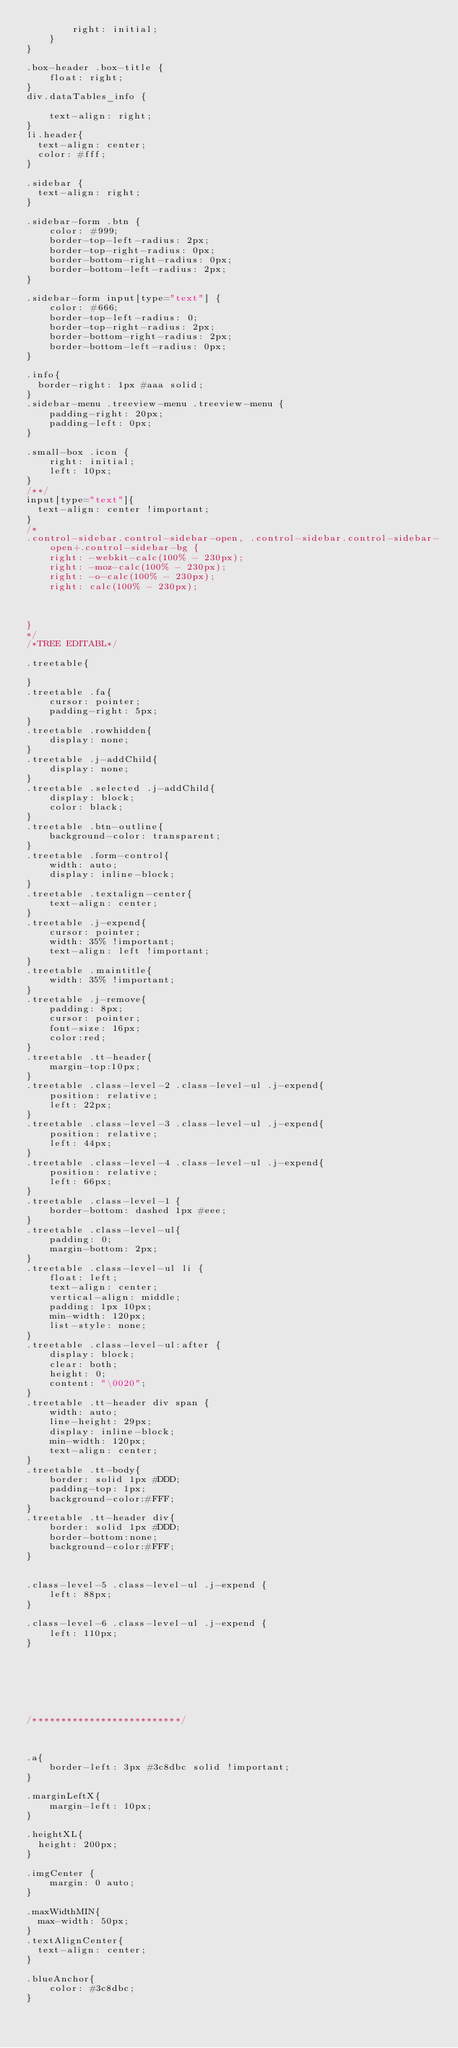<code> <loc_0><loc_0><loc_500><loc_500><_CSS_>        right: initial;
    }
}

.box-header .box-title {
    float: right;
}
div.dataTables_info {

    text-align: right;
}
li.header{
	text-align: center;
	color: #fff;
}

.sidebar {
	text-align: right;
}

.sidebar-form .btn {
    color: #999;
    border-top-left-radius: 2px;
    border-top-right-radius: 0px;
    border-bottom-right-radius: 0px;
    border-bottom-left-radius: 2px;
}

.sidebar-form input[type="text"] {
    color: #666;
    border-top-left-radius: 0;
    border-top-right-radius: 2px;
    border-bottom-right-radius: 2px;
    border-bottom-left-radius: 0px;    
}

.info{
	border-right: 1px #aaa solid;
}
.sidebar-menu .treeview-menu .treeview-menu {
    padding-right: 20px;
    padding-left: 0px;
}

.small-box .icon {
    right: initial;
    left: 10px;
}
/**/
input[type="text"]{
	text-align: center !important;
}
/*
.control-sidebar.control-sidebar-open, .control-sidebar.control-sidebar-open+.control-sidebar-bg {
    right: -webkit-calc(100% - 230px);
    right: -moz-calc(100% - 230px);
    right: -o-calc(100% - 230px);
    right: calc(100% - 230px);



}
*/
/*TREE EDITABL*/

.treetable{

}
.treetable .fa{
    cursor: pointer;
    padding-right: 5px;
}
.treetable .rowhidden{
    display: none;
}
.treetable .j-addChild{
    display: none;
}
.treetable .selected .j-addChild{
    display: block;
    color: black;
}
.treetable .btn-outline{
    background-color: transparent;
}
.treetable .form-control{
    width: auto;
    display: inline-block;
}
.treetable .textalign-center{
    text-align: center;
}
.treetable .j-expend{
    cursor: pointer;
    width: 35% !important;
    text-align: left !important;
}
.treetable .maintitle{
    width: 35% !important;
}
.treetable .j-remove{
    padding: 8px;
    cursor: pointer;
    font-size: 16px;
    color:red;
}
.treetable .tt-header{
    margin-top:10px;
}
.treetable .class-level-2 .class-level-ul .j-expend{
    position: relative;
    left: 22px;
}
.treetable .class-level-3 .class-level-ul .j-expend{
    position: relative;
    left: 44px;
}
.treetable .class-level-4 .class-level-ul .j-expend{
    position: relative;
    left: 66px;
}
.treetable .class-level-1 {
    border-bottom: dashed 1px #eee;
}
.treetable .class-level-ul{
    padding: 0;
    margin-bottom: 2px;
}
.treetable .class-level-ul li {
    float: left;
    text-align: center;
    vertical-align: middle;
    padding: 1px 10px;
    min-width: 120px;
    list-style: none;
}
.treetable .class-level-ul:after {
    display: block;
    clear: both;
    height: 0;
    content: "\0020";
}
.treetable .tt-header div span {
    width: auto;
    line-height: 29px;
    display: inline-block;
    min-width: 120px;
    text-align: center;
}
.treetable .tt-body{
    border: solid 1px #DDD;
    padding-top: 1px;
    background-color:#FFF;
}
.treetable .tt-header div{
    border: solid 1px #DDD;
    border-bottom:none;
    background-color:#FFF;
}


.class-level-5 .class-level-ul .j-expend {
    left: 88px;
}

.class-level-6 .class-level-ul .j-expend {
    left: 110px;
}







/**************************/



.a{
    border-left: 3px #3c8dbc solid !important;
}

.marginLeftX{
    margin-left: 10px;
}

.heightXL{
	height: 200px;
}

.imgCenter {
    margin: 0 auto;
}

.maxWidthMIN{
	max-width: 50px;
}
.textAlignCenter{
	text-align: center;
}

.blueAnchor{
    color: #3c8dbc;
}
</code> 